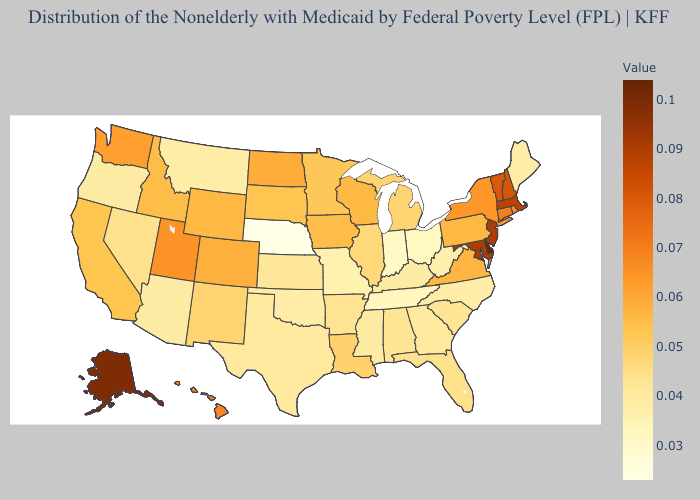Which states have the highest value in the USA?
Write a very short answer. Delaware. Does Michigan have the lowest value in the USA?
Quick response, please. No. Which states have the highest value in the USA?
Concise answer only. Delaware. Which states have the lowest value in the West?
Short answer required. Montana. Among the states that border Texas , does Arkansas have the lowest value?
Keep it brief. No. 